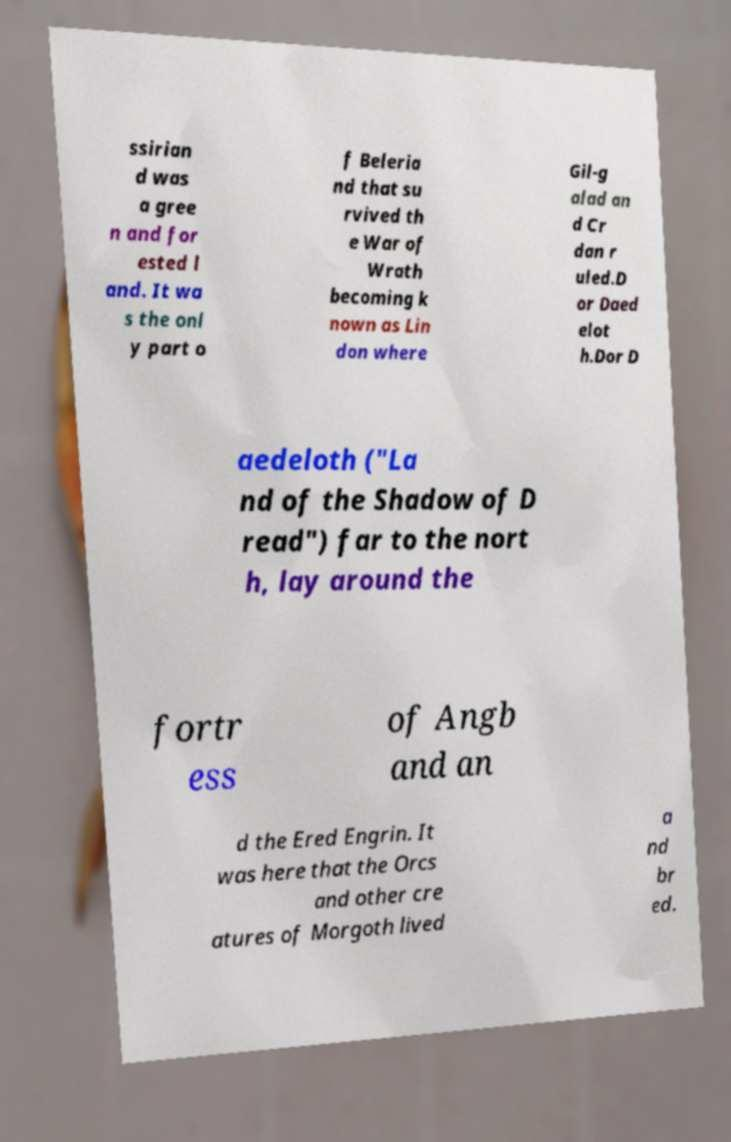Could you assist in decoding the text presented in this image and type it out clearly? ssirian d was a gree n and for ested l and. It wa s the onl y part o f Beleria nd that su rvived th e War of Wrath becoming k nown as Lin don where Gil-g alad an d Cr dan r uled.D or Daed elot h.Dor D aedeloth ("La nd of the Shadow of D read") far to the nort h, lay around the fortr ess of Angb and an d the Ered Engrin. It was here that the Orcs and other cre atures of Morgoth lived a nd br ed. 